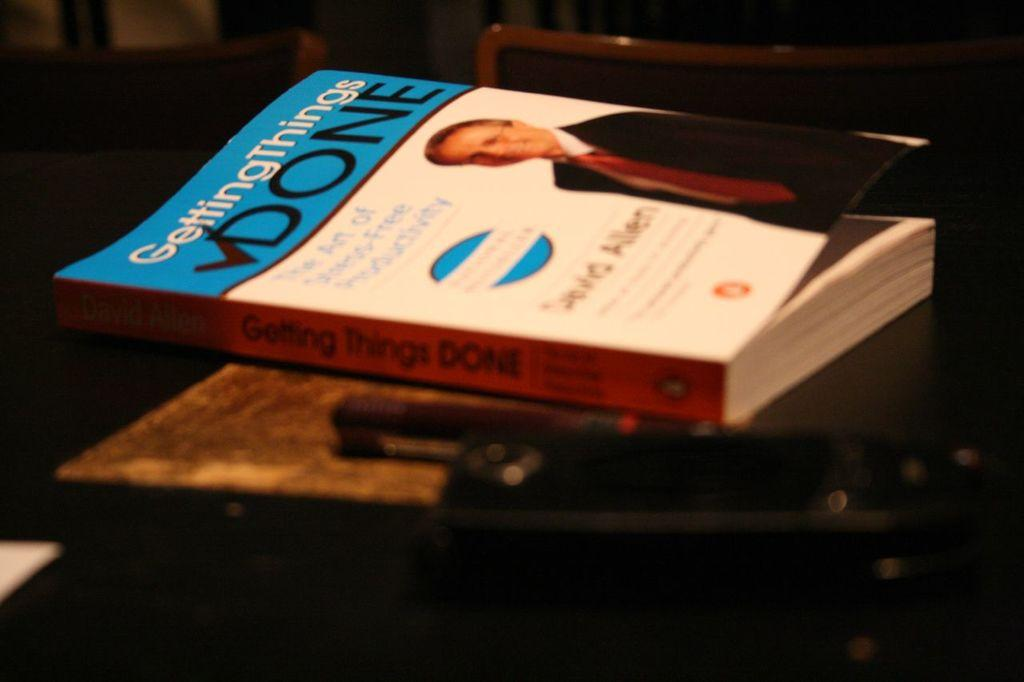<image>
Give a short and clear explanation of the subsequent image. "GettingThings Done", is the title of the book on the table. 